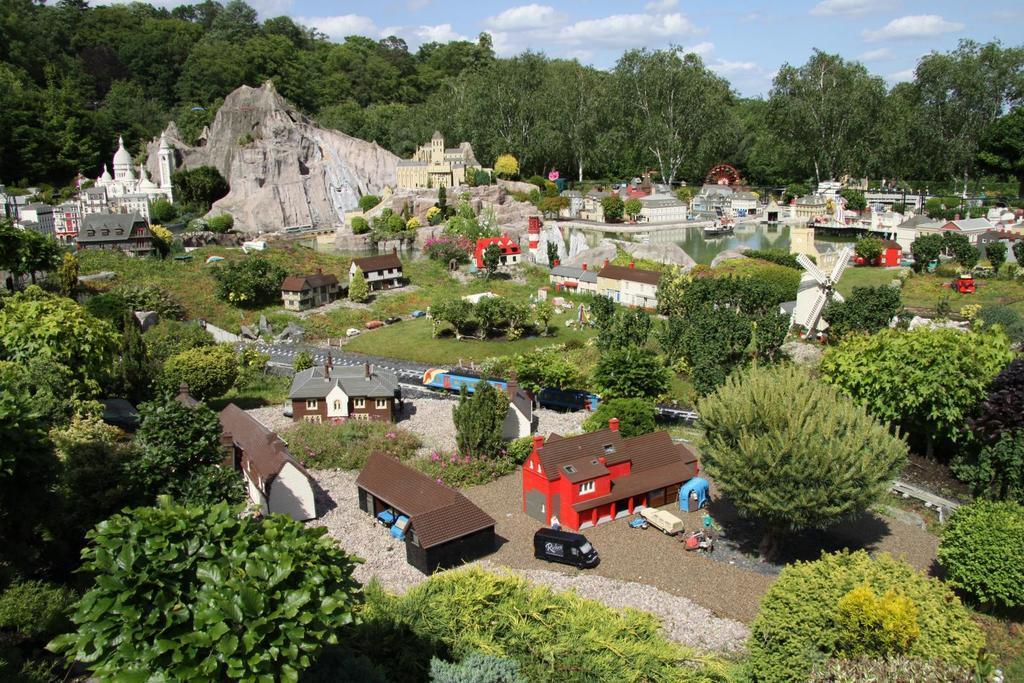Please provide a concise description of this image. In this picture I can see the building, shed, poles and other objects. In the back there is a mountain. At the bottom there is a black color van and other vehicles. In the background I can see many trees and grass. At the top I can see the sky and clouds. 